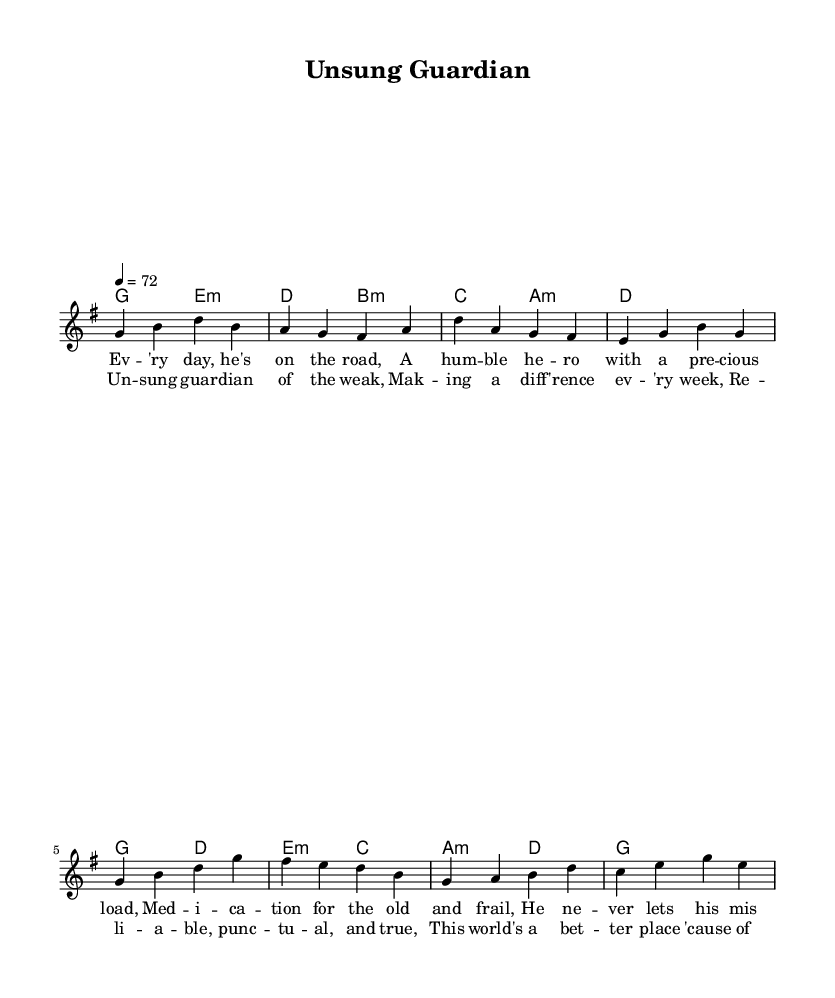What is the key signature of this music? The key signature is G major, indicated by one sharp (F#) in the key signature at the beginning of the staff.
Answer: G major What is the time signature of this music? The time signature is 4/4, which means there are four beats per measure and a quarter note gets one beat, visible at the beginning of the score.
Answer: 4/4 What is the tempo marking of this piece? The tempo marking indicates a speed of 72 beats per minute, as seen directly in the tempo indication at the start of the music.
Answer: 72 How many measures are in the verse? The verse section consists of four measures as shown in the melody line labeled for the verse. Each line of notes separated by vertical lines indicates one measure.
Answer: 4 Which chord follows the first melody note in the chorus? The first melody note in the chorus is G, and it is followed by the chord G major in the harmonies section right underneath the melody notes.
Answer: G What type of vocal style is this song likely to represent in the rock genre? The lyrics emphasize an emotional narrative, which is characteristic of a rock ballad as it focuses on storytelling about unsung heroes and their importance in life.
Answer: Rock ballad What is the lyrical theme of this piece? The lyrics highlight values such as reliability and making a difference in people’s lives, suggesting a theme of appreciation for those who help others, aligning with the context of unsung heroes.
Answer: Unsung heroes 